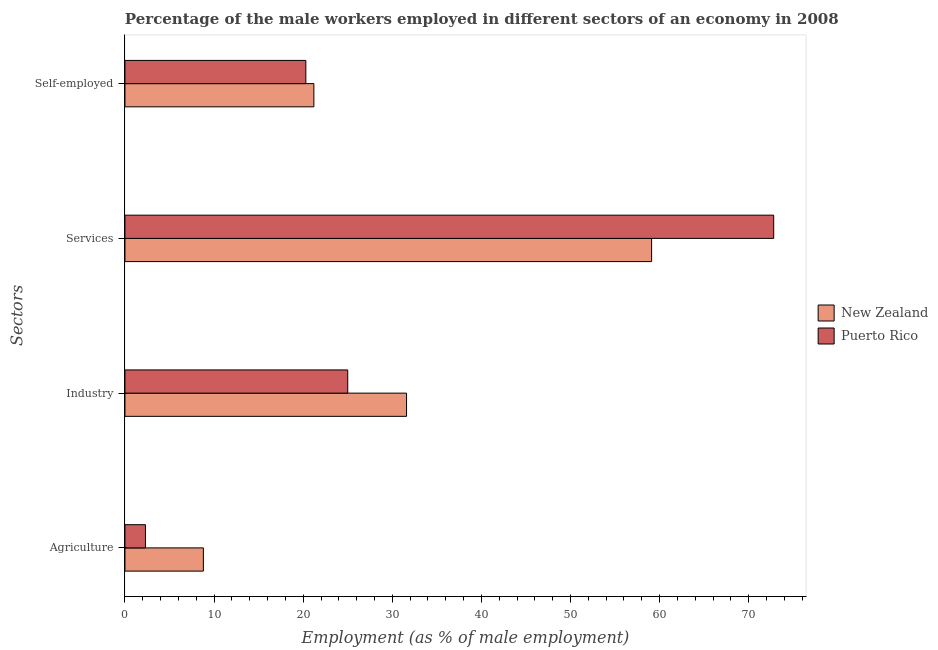How many groups of bars are there?
Offer a very short reply. 4. Are the number of bars on each tick of the Y-axis equal?
Your answer should be very brief. Yes. How many bars are there on the 2nd tick from the bottom?
Your answer should be compact. 2. What is the label of the 2nd group of bars from the top?
Give a very brief answer. Services. What is the percentage of male workers in agriculture in Puerto Rico?
Keep it short and to the point. 2.3. Across all countries, what is the maximum percentage of male workers in services?
Make the answer very short. 72.8. Across all countries, what is the minimum percentage of self employed male workers?
Your answer should be very brief. 20.3. In which country was the percentage of male workers in agriculture maximum?
Your answer should be very brief. New Zealand. In which country was the percentage of male workers in industry minimum?
Your answer should be compact. Puerto Rico. What is the total percentage of male workers in services in the graph?
Your answer should be compact. 131.9. What is the difference between the percentage of male workers in agriculture in New Zealand and that in Puerto Rico?
Your response must be concise. 6.5. What is the difference between the percentage of self employed male workers in Puerto Rico and the percentage of male workers in services in New Zealand?
Offer a terse response. -38.8. What is the average percentage of male workers in industry per country?
Give a very brief answer. 28.3. What is the difference between the percentage of male workers in services and percentage of male workers in agriculture in New Zealand?
Offer a very short reply. 50.3. What is the ratio of the percentage of male workers in industry in New Zealand to that in Puerto Rico?
Make the answer very short. 1.26. Is the difference between the percentage of self employed male workers in Puerto Rico and New Zealand greater than the difference between the percentage of male workers in services in Puerto Rico and New Zealand?
Provide a succinct answer. No. What is the difference between the highest and the second highest percentage of male workers in agriculture?
Offer a terse response. 6.5. What is the difference between the highest and the lowest percentage of male workers in industry?
Offer a very short reply. 6.6. What does the 2nd bar from the top in Self-employed represents?
Provide a short and direct response. New Zealand. What does the 1st bar from the bottom in Industry represents?
Your answer should be compact. New Zealand. Is it the case that in every country, the sum of the percentage of male workers in agriculture and percentage of male workers in industry is greater than the percentage of male workers in services?
Provide a succinct answer. No. How many bars are there?
Offer a terse response. 8. What is the difference between two consecutive major ticks on the X-axis?
Offer a terse response. 10. How many legend labels are there?
Ensure brevity in your answer.  2. What is the title of the graph?
Offer a terse response. Percentage of the male workers employed in different sectors of an economy in 2008. Does "Panama" appear as one of the legend labels in the graph?
Provide a succinct answer. No. What is the label or title of the X-axis?
Your answer should be compact. Employment (as % of male employment). What is the label or title of the Y-axis?
Offer a terse response. Sectors. What is the Employment (as % of male employment) in New Zealand in Agriculture?
Give a very brief answer. 8.8. What is the Employment (as % of male employment) of Puerto Rico in Agriculture?
Provide a short and direct response. 2.3. What is the Employment (as % of male employment) of New Zealand in Industry?
Your answer should be compact. 31.6. What is the Employment (as % of male employment) in New Zealand in Services?
Make the answer very short. 59.1. What is the Employment (as % of male employment) of Puerto Rico in Services?
Provide a succinct answer. 72.8. What is the Employment (as % of male employment) of New Zealand in Self-employed?
Offer a very short reply. 21.2. What is the Employment (as % of male employment) in Puerto Rico in Self-employed?
Make the answer very short. 20.3. Across all Sectors, what is the maximum Employment (as % of male employment) in New Zealand?
Offer a very short reply. 59.1. Across all Sectors, what is the maximum Employment (as % of male employment) of Puerto Rico?
Give a very brief answer. 72.8. Across all Sectors, what is the minimum Employment (as % of male employment) of New Zealand?
Provide a succinct answer. 8.8. Across all Sectors, what is the minimum Employment (as % of male employment) of Puerto Rico?
Offer a terse response. 2.3. What is the total Employment (as % of male employment) of New Zealand in the graph?
Provide a short and direct response. 120.7. What is the total Employment (as % of male employment) of Puerto Rico in the graph?
Keep it short and to the point. 120.4. What is the difference between the Employment (as % of male employment) of New Zealand in Agriculture and that in Industry?
Offer a terse response. -22.8. What is the difference between the Employment (as % of male employment) of Puerto Rico in Agriculture and that in Industry?
Provide a succinct answer. -22.7. What is the difference between the Employment (as % of male employment) of New Zealand in Agriculture and that in Services?
Give a very brief answer. -50.3. What is the difference between the Employment (as % of male employment) of Puerto Rico in Agriculture and that in Services?
Make the answer very short. -70.5. What is the difference between the Employment (as % of male employment) in New Zealand in Agriculture and that in Self-employed?
Your answer should be very brief. -12.4. What is the difference between the Employment (as % of male employment) in Puerto Rico in Agriculture and that in Self-employed?
Keep it short and to the point. -18. What is the difference between the Employment (as % of male employment) in New Zealand in Industry and that in Services?
Your response must be concise. -27.5. What is the difference between the Employment (as % of male employment) in Puerto Rico in Industry and that in Services?
Offer a terse response. -47.8. What is the difference between the Employment (as % of male employment) of New Zealand in Industry and that in Self-employed?
Provide a short and direct response. 10.4. What is the difference between the Employment (as % of male employment) in New Zealand in Services and that in Self-employed?
Ensure brevity in your answer.  37.9. What is the difference between the Employment (as % of male employment) in Puerto Rico in Services and that in Self-employed?
Offer a very short reply. 52.5. What is the difference between the Employment (as % of male employment) in New Zealand in Agriculture and the Employment (as % of male employment) in Puerto Rico in Industry?
Your answer should be compact. -16.2. What is the difference between the Employment (as % of male employment) of New Zealand in Agriculture and the Employment (as % of male employment) of Puerto Rico in Services?
Your response must be concise. -64. What is the difference between the Employment (as % of male employment) of New Zealand in Industry and the Employment (as % of male employment) of Puerto Rico in Services?
Your answer should be compact. -41.2. What is the difference between the Employment (as % of male employment) of New Zealand in Industry and the Employment (as % of male employment) of Puerto Rico in Self-employed?
Your answer should be compact. 11.3. What is the difference between the Employment (as % of male employment) of New Zealand in Services and the Employment (as % of male employment) of Puerto Rico in Self-employed?
Your response must be concise. 38.8. What is the average Employment (as % of male employment) in New Zealand per Sectors?
Your answer should be very brief. 30.18. What is the average Employment (as % of male employment) in Puerto Rico per Sectors?
Offer a very short reply. 30.1. What is the difference between the Employment (as % of male employment) of New Zealand and Employment (as % of male employment) of Puerto Rico in Agriculture?
Make the answer very short. 6.5. What is the difference between the Employment (as % of male employment) in New Zealand and Employment (as % of male employment) in Puerto Rico in Services?
Your answer should be very brief. -13.7. What is the difference between the Employment (as % of male employment) in New Zealand and Employment (as % of male employment) in Puerto Rico in Self-employed?
Your response must be concise. 0.9. What is the ratio of the Employment (as % of male employment) in New Zealand in Agriculture to that in Industry?
Your answer should be compact. 0.28. What is the ratio of the Employment (as % of male employment) of Puerto Rico in Agriculture to that in Industry?
Offer a terse response. 0.09. What is the ratio of the Employment (as % of male employment) in New Zealand in Agriculture to that in Services?
Offer a very short reply. 0.15. What is the ratio of the Employment (as % of male employment) in Puerto Rico in Agriculture to that in Services?
Your answer should be very brief. 0.03. What is the ratio of the Employment (as % of male employment) of New Zealand in Agriculture to that in Self-employed?
Provide a succinct answer. 0.42. What is the ratio of the Employment (as % of male employment) of Puerto Rico in Agriculture to that in Self-employed?
Make the answer very short. 0.11. What is the ratio of the Employment (as % of male employment) of New Zealand in Industry to that in Services?
Your answer should be compact. 0.53. What is the ratio of the Employment (as % of male employment) of Puerto Rico in Industry to that in Services?
Your answer should be very brief. 0.34. What is the ratio of the Employment (as % of male employment) in New Zealand in Industry to that in Self-employed?
Your answer should be very brief. 1.49. What is the ratio of the Employment (as % of male employment) in Puerto Rico in Industry to that in Self-employed?
Your answer should be compact. 1.23. What is the ratio of the Employment (as % of male employment) of New Zealand in Services to that in Self-employed?
Ensure brevity in your answer.  2.79. What is the ratio of the Employment (as % of male employment) of Puerto Rico in Services to that in Self-employed?
Give a very brief answer. 3.59. What is the difference between the highest and the second highest Employment (as % of male employment) in New Zealand?
Make the answer very short. 27.5. What is the difference between the highest and the second highest Employment (as % of male employment) of Puerto Rico?
Provide a succinct answer. 47.8. What is the difference between the highest and the lowest Employment (as % of male employment) of New Zealand?
Give a very brief answer. 50.3. What is the difference between the highest and the lowest Employment (as % of male employment) in Puerto Rico?
Your answer should be compact. 70.5. 